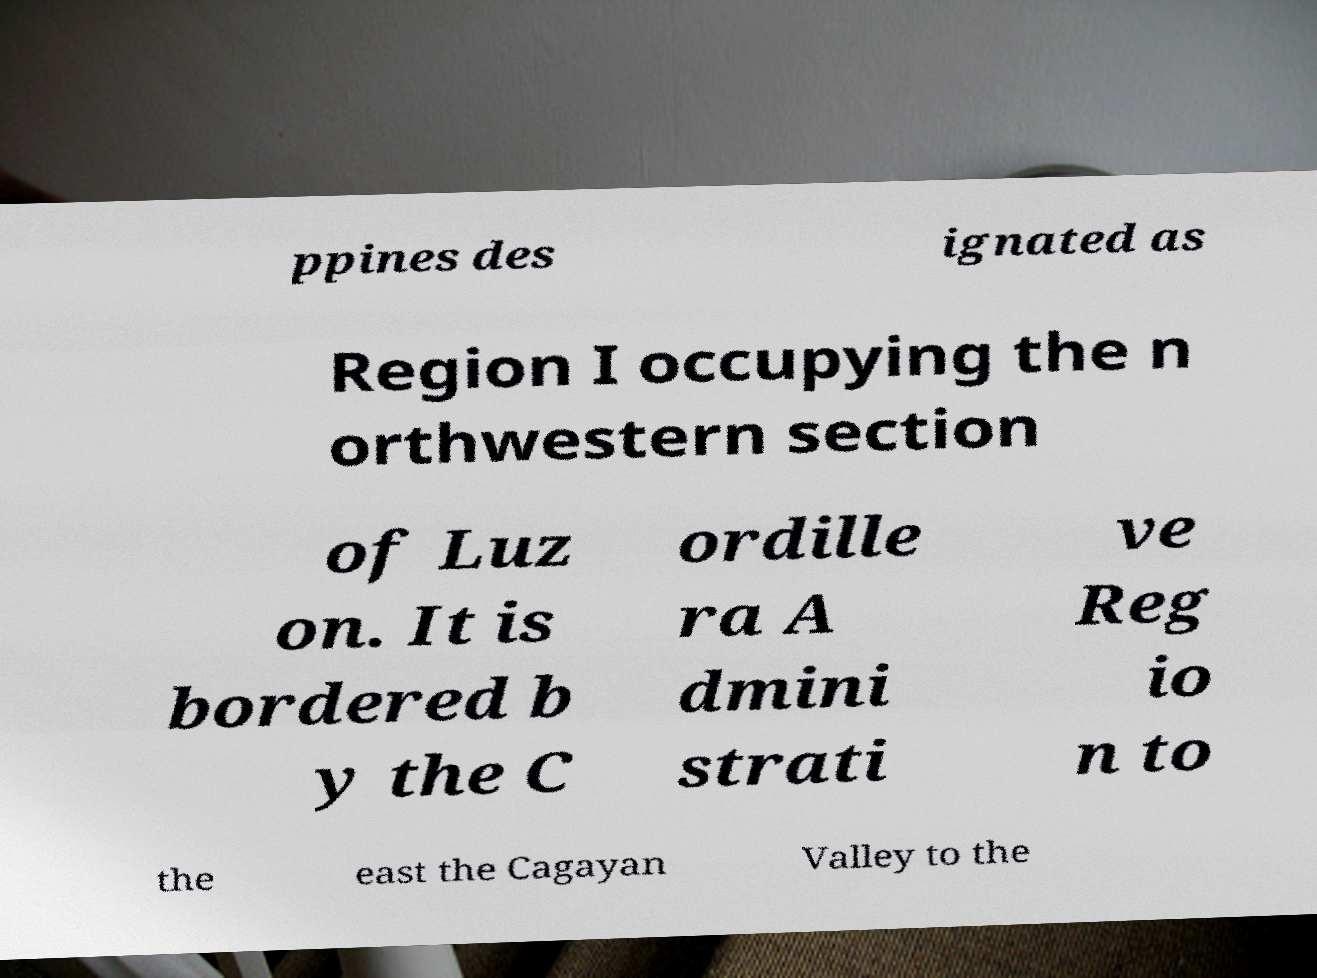Can you read and provide the text displayed in the image?This photo seems to have some interesting text. Can you extract and type it out for me? ppines des ignated as Region I occupying the n orthwestern section of Luz on. It is bordered b y the C ordille ra A dmini strati ve Reg io n to the east the Cagayan Valley to the 